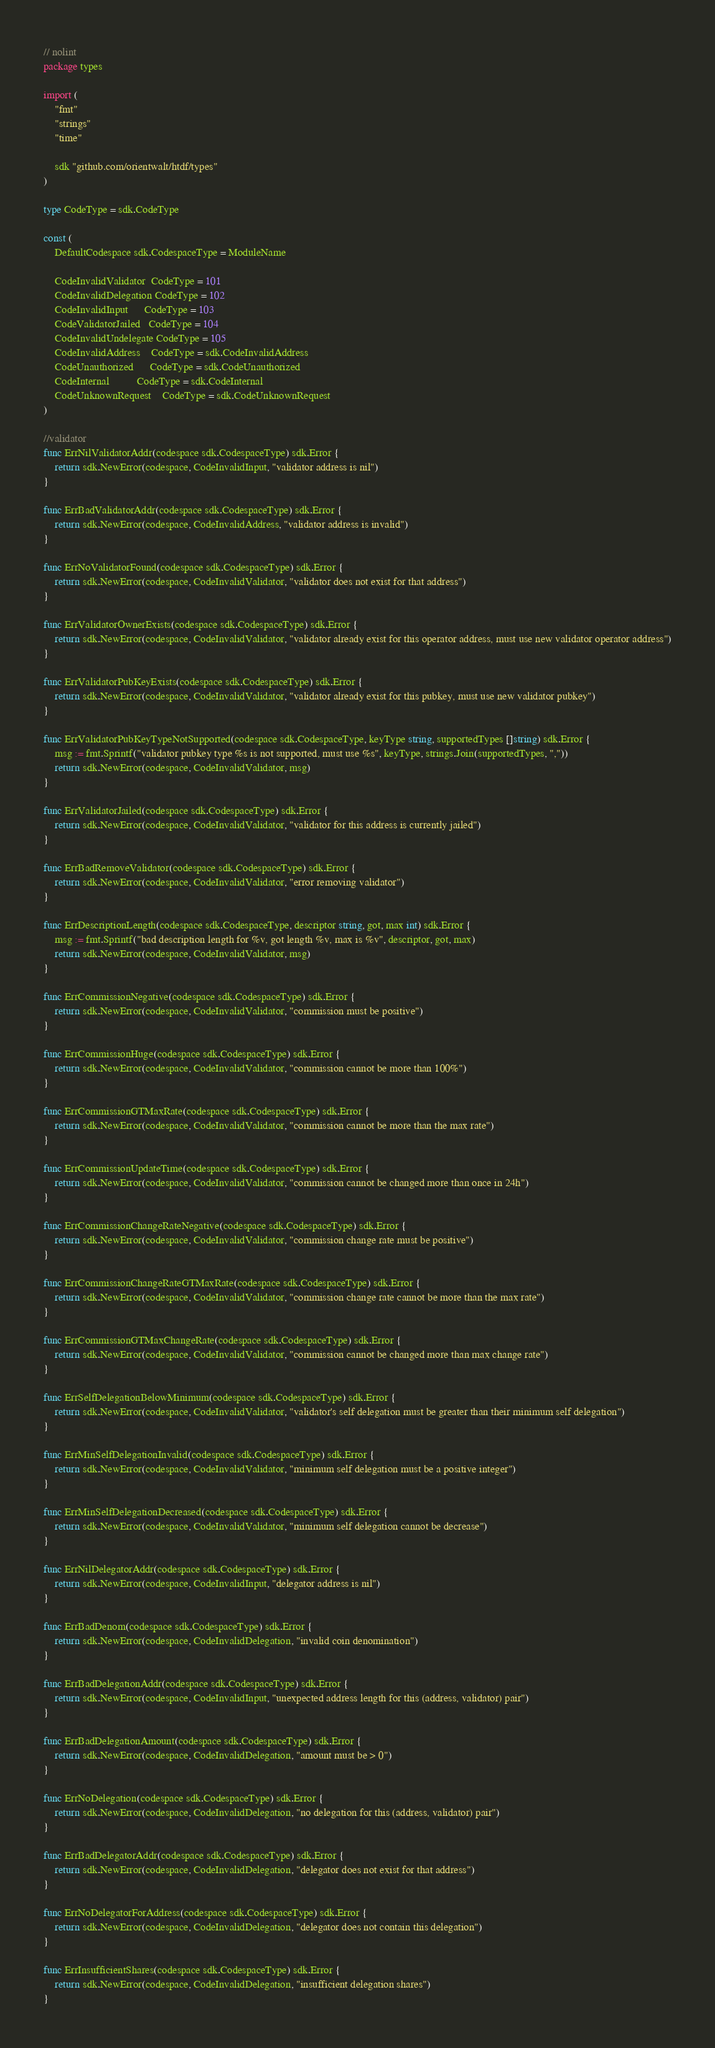<code> <loc_0><loc_0><loc_500><loc_500><_Go_>// nolint
package types

import (
	"fmt"
	"strings"
	"time"

	sdk "github.com/orientwalt/htdf/types"
)

type CodeType = sdk.CodeType

const (
	DefaultCodespace sdk.CodespaceType = ModuleName

	CodeInvalidValidator  CodeType = 101
	CodeInvalidDelegation CodeType = 102
	CodeInvalidInput      CodeType = 103
	CodeValidatorJailed   CodeType = 104
	CodeInvalidUndelegate CodeType = 105
	CodeInvalidAddress    CodeType = sdk.CodeInvalidAddress
	CodeUnauthorized      CodeType = sdk.CodeUnauthorized
	CodeInternal          CodeType = sdk.CodeInternal
	CodeUnknownRequest    CodeType = sdk.CodeUnknownRequest
)

//validator
func ErrNilValidatorAddr(codespace sdk.CodespaceType) sdk.Error {
	return sdk.NewError(codespace, CodeInvalidInput, "validator address is nil")
}

func ErrBadValidatorAddr(codespace sdk.CodespaceType) sdk.Error {
	return sdk.NewError(codespace, CodeInvalidAddress, "validator address is invalid")
}

func ErrNoValidatorFound(codespace sdk.CodespaceType) sdk.Error {
	return sdk.NewError(codespace, CodeInvalidValidator, "validator does not exist for that address")
}

func ErrValidatorOwnerExists(codespace sdk.CodespaceType) sdk.Error {
	return sdk.NewError(codespace, CodeInvalidValidator, "validator already exist for this operator address, must use new validator operator address")
}

func ErrValidatorPubKeyExists(codespace sdk.CodespaceType) sdk.Error {
	return sdk.NewError(codespace, CodeInvalidValidator, "validator already exist for this pubkey, must use new validator pubkey")
}

func ErrValidatorPubKeyTypeNotSupported(codespace sdk.CodespaceType, keyType string, supportedTypes []string) sdk.Error {
	msg := fmt.Sprintf("validator pubkey type %s is not supported, must use %s", keyType, strings.Join(supportedTypes, ","))
	return sdk.NewError(codespace, CodeInvalidValidator, msg)
}

func ErrValidatorJailed(codespace sdk.CodespaceType) sdk.Error {
	return sdk.NewError(codespace, CodeInvalidValidator, "validator for this address is currently jailed")
}

func ErrBadRemoveValidator(codespace sdk.CodespaceType) sdk.Error {
	return sdk.NewError(codespace, CodeInvalidValidator, "error removing validator")
}

func ErrDescriptionLength(codespace sdk.CodespaceType, descriptor string, got, max int) sdk.Error {
	msg := fmt.Sprintf("bad description length for %v, got length %v, max is %v", descriptor, got, max)
	return sdk.NewError(codespace, CodeInvalidValidator, msg)
}

func ErrCommissionNegative(codespace sdk.CodespaceType) sdk.Error {
	return sdk.NewError(codespace, CodeInvalidValidator, "commission must be positive")
}

func ErrCommissionHuge(codespace sdk.CodespaceType) sdk.Error {
	return sdk.NewError(codespace, CodeInvalidValidator, "commission cannot be more than 100%")
}

func ErrCommissionGTMaxRate(codespace sdk.CodespaceType) sdk.Error {
	return sdk.NewError(codespace, CodeInvalidValidator, "commission cannot be more than the max rate")
}

func ErrCommissionUpdateTime(codespace sdk.CodespaceType) sdk.Error {
	return sdk.NewError(codespace, CodeInvalidValidator, "commission cannot be changed more than once in 24h")
}

func ErrCommissionChangeRateNegative(codespace sdk.CodespaceType) sdk.Error {
	return sdk.NewError(codespace, CodeInvalidValidator, "commission change rate must be positive")
}

func ErrCommissionChangeRateGTMaxRate(codespace sdk.CodespaceType) sdk.Error {
	return sdk.NewError(codespace, CodeInvalidValidator, "commission change rate cannot be more than the max rate")
}

func ErrCommissionGTMaxChangeRate(codespace sdk.CodespaceType) sdk.Error {
	return sdk.NewError(codespace, CodeInvalidValidator, "commission cannot be changed more than max change rate")
}

func ErrSelfDelegationBelowMinimum(codespace sdk.CodespaceType) sdk.Error {
	return sdk.NewError(codespace, CodeInvalidValidator, "validator's self delegation must be greater than their minimum self delegation")
}

func ErrMinSelfDelegationInvalid(codespace sdk.CodespaceType) sdk.Error {
	return sdk.NewError(codespace, CodeInvalidValidator, "minimum self delegation must be a positive integer")
}

func ErrMinSelfDelegationDecreased(codespace sdk.CodespaceType) sdk.Error {
	return sdk.NewError(codespace, CodeInvalidValidator, "minimum self delegation cannot be decrease")
}

func ErrNilDelegatorAddr(codespace sdk.CodespaceType) sdk.Error {
	return sdk.NewError(codespace, CodeInvalidInput, "delegator address is nil")
}

func ErrBadDenom(codespace sdk.CodespaceType) sdk.Error {
	return sdk.NewError(codespace, CodeInvalidDelegation, "invalid coin denomination")
}

func ErrBadDelegationAddr(codespace sdk.CodespaceType) sdk.Error {
	return sdk.NewError(codespace, CodeInvalidInput, "unexpected address length for this (address, validator) pair")
}

func ErrBadDelegationAmount(codespace sdk.CodespaceType) sdk.Error {
	return sdk.NewError(codespace, CodeInvalidDelegation, "amount must be > 0")
}

func ErrNoDelegation(codespace sdk.CodespaceType) sdk.Error {
	return sdk.NewError(codespace, CodeInvalidDelegation, "no delegation for this (address, validator) pair")
}

func ErrBadDelegatorAddr(codespace sdk.CodespaceType) sdk.Error {
	return sdk.NewError(codespace, CodeInvalidDelegation, "delegator does not exist for that address")
}

func ErrNoDelegatorForAddress(codespace sdk.CodespaceType) sdk.Error {
	return sdk.NewError(codespace, CodeInvalidDelegation, "delegator does not contain this delegation")
}

func ErrInsufficientShares(codespace sdk.CodespaceType) sdk.Error {
	return sdk.NewError(codespace, CodeInvalidDelegation, "insufficient delegation shares")
}
</code> 